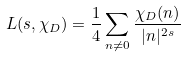Convert formula to latex. <formula><loc_0><loc_0><loc_500><loc_500>L ( s , \chi _ { D } ) = \frac { 1 } { 4 } \sum _ { n \neq 0 } \frac { \chi _ { D } ( n ) } { | n | ^ { 2 s } }</formula> 